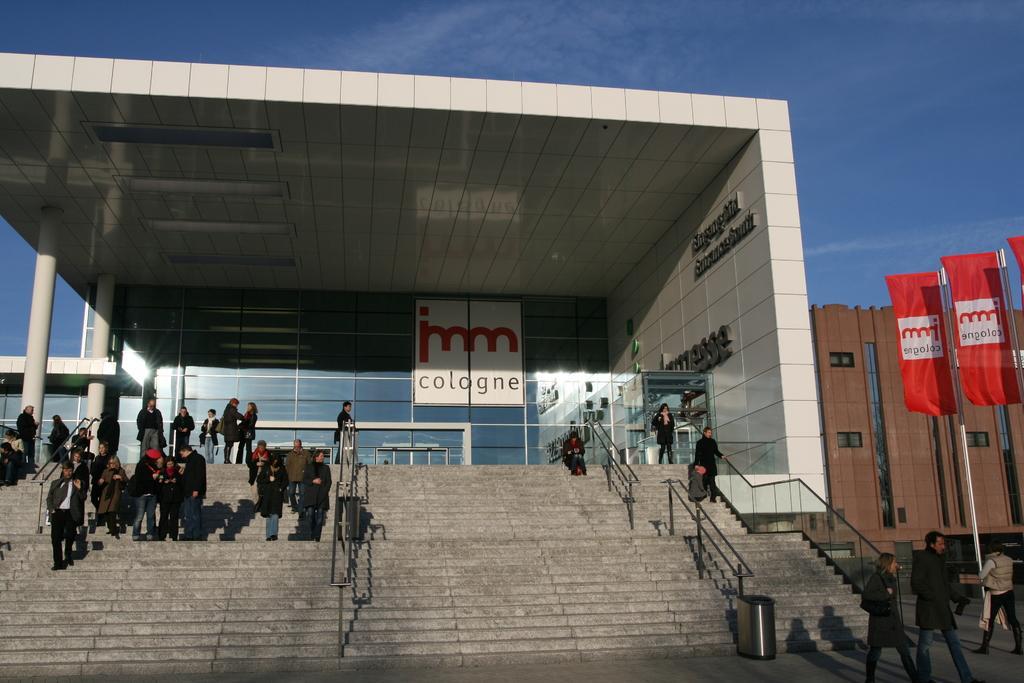How would you summarize this image in a sentence or two? In the image there are steps with railing and few people are walking. And also there is a dustbin. In the background there is a building with name boards, walls, glass doors and pillars. On the right side of the image there are few poles with flags. Behind them there is a building with windows and walls. At the top of the image there is a sky. 